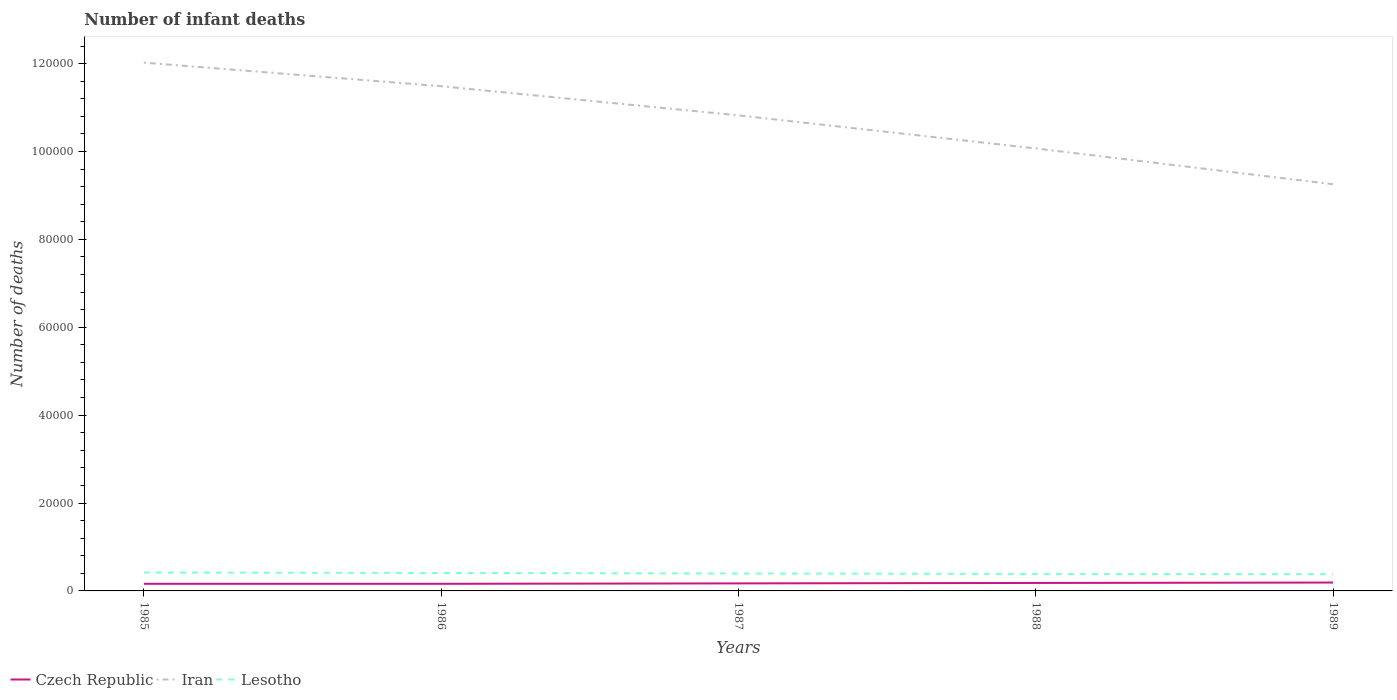How many different coloured lines are there?
Your response must be concise. 3. Is the number of lines equal to the number of legend labels?
Give a very brief answer. Yes. Across all years, what is the maximum number of infant deaths in Iran?
Offer a terse response. 9.25e+04. In which year was the number of infant deaths in Lesotho maximum?
Your answer should be compact. 1989. What is the total number of infant deaths in Czech Republic in the graph?
Provide a succinct answer. -283. What is the difference between the highest and the second highest number of infant deaths in Czech Republic?
Offer a terse response. 283. Is the number of infant deaths in Czech Republic strictly greater than the number of infant deaths in Iran over the years?
Your answer should be compact. Yes. How many lines are there?
Ensure brevity in your answer.  3. How many years are there in the graph?
Offer a terse response. 5. What is the difference between two consecutive major ticks on the Y-axis?
Provide a succinct answer. 2.00e+04. Does the graph contain grids?
Keep it short and to the point. No. What is the title of the graph?
Offer a terse response. Number of infant deaths. Does "Suriname" appear as one of the legend labels in the graph?
Your response must be concise. No. What is the label or title of the X-axis?
Ensure brevity in your answer.  Years. What is the label or title of the Y-axis?
Offer a terse response. Number of deaths. What is the Number of deaths of Czech Republic in 1985?
Offer a terse response. 1622. What is the Number of deaths in Iran in 1985?
Keep it short and to the point. 1.20e+05. What is the Number of deaths of Lesotho in 1985?
Make the answer very short. 4196. What is the Number of deaths in Czech Republic in 1986?
Offer a very short reply. 1622. What is the Number of deaths of Iran in 1986?
Ensure brevity in your answer.  1.15e+05. What is the Number of deaths of Lesotho in 1986?
Your answer should be very brief. 4080. What is the Number of deaths in Czech Republic in 1987?
Keep it short and to the point. 1714. What is the Number of deaths in Iran in 1987?
Your answer should be compact. 1.08e+05. What is the Number of deaths in Lesotho in 1987?
Offer a very short reply. 3973. What is the Number of deaths of Czech Republic in 1988?
Offer a terse response. 1814. What is the Number of deaths of Iran in 1988?
Your answer should be very brief. 1.01e+05. What is the Number of deaths of Lesotho in 1988?
Keep it short and to the point. 3871. What is the Number of deaths of Czech Republic in 1989?
Make the answer very short. 1905. What is the Number of deaths of Iran in 1989?
Your answer should be very brief. 9.25e+04. What is the Number of deaths in Lesotho in 1989?
Your answer should be compact. 3809. Across all years, what is the maximum Number of deaths in Czech Republic?
Make the answer very short. 1905. Across all years, what is the maximum Number of deaths in Iran?
Offer a very short reply. 1.20e+05. Across all years, what is the maximum Number of deaths of Lesotho?
Ensure brevity in your answer.  4196. Across all years, what is the minimum Number of deaths of Czech Republic?
Offer a terse response. 1622. Across all years, what is the minimum Number of deaths in Iran?
Make the answer very short. 9.25e+04. Across all years, what is the minimum Number of deaths of Lesotho?
Offer a very short reply. 3809. What is the total Number of deaths in Czech Republic in the graph?
Offer a very short reply. 8677. What is the total Number of deaths of Iran in the graph?
Your answer should be very brief. 5.37e+05. What is the total Number of deaths of Lesotho in the graph?
Ensure brevity in your answer.  1.99e+04. What is the difference between the Number of deaths of Iran in 1985 and that in 1986?
Make the answer very short. 5364. What is the difference between the Number of deaths in Lesotho in 1985 and that in 1986?
Your response must be concise. 116. What is the difference between the Number of deaths in Czech Republic in 1985 and that in 1987?
Your answer should be compact. -92. What is the difference between the Number of deaths of Iran in 1985 and that in 1987?
Your response must be concise. 1.20e+04. What is the difference between the Number of deaths of Lesotho in 1985 and that in 1987?
Make the answer very short. 223. What is the difference between the Number of deaths in Czech Republic in 1985 and that in 1988?
Your answer should be compact. -192. What is the difference between the Number of deaths of Iran in 1985 and that in 1988?
Your answer should be very brief. 1.95e+04. What is the difference between the Number of deaths of Lesotho in 1985 and that in 1988?
Make the answer very short. 325. What is the difference between the Number of deaths of Czech Republic in 1985 and that in 1989?
Your answer should be very brief. -283. What is the difference between the Number of deaths of Iran in 1985 and that in 1989?
Provide a short and direct response. 2.77e+04. What is the difference between the Number of deaths of Lesotho in 1985 and that in 1989?
Your answer should be very brief. 387. What is the difference between the Number of deaths in Czech Republic in 1986 and that in 1987?
Your answer should be compact. -92. What is the difference between the Number of deaths of Iran in 1986 and that in 1987?
Your answer should be very brief. 6638. What is the difference between the Number of deaths in Lesotho in 1986 and that in 1987?
Ensure brevity in your answer.  107. What is the difference between the Number of deaths of Czech Republic in 1986 and that in 1988?
Your answer should be compact. -192. What is the difference between the Number of deaths of Iran in 1986 and that in 1988?
Provide a short and direct response. 1.42e+04. What is the difference between the Number of deaths in Lesotho in 1986 and that in 1988?
Provide a succinct answer. 209. What is the difference between the Number of deaths in Czech Republic in 1986 and that in 1989?
Offer a very short reply. -283. What is the difference between the Number of deaths in Iran in 1986 and that in 1989?
Offer a very short reply. 2.23e+04. What is the difference between the Number of deaths in Lesotho in 1986 and that in 1989?
Offer a very short reply. 271. What is the difference between the Number of deaths of Czech Republic in 1987 and that in 1988?
Ensure brevity in your answer.  -100. What is the difference between the Number of deaths in Iran in 1987 and that in 1988?
Provide a short and direct response. 7524. What is the difference between the Number of deaths of Lesotho in 1987 and that in 1988?
Provide a succinct answer. 102. What is the difference between the Number of deaths in Czech Republic in 1987 and that in 1989?
Make the answer very short. -191. What is the difference between the Number of deaths of Iran in 1987 and that in 1989?
Your answer should be very brief. 1.57e+04. What is the difference between the Number of deaths in Lesotho in 1987 and that in 1989?
Your answer should be very brief. 164. What is the difference between the Number of deaths in Czech Republic in 1988 and that in 1989?
Offer a very short reply. -91. What is the difference between the Number of deaths in Iran in 1988 and that in 1989?
Offer a terse response. 8149. What is the difference between the Number of deaths of Czech Republic in 1985 and the Number of deaths of Iran in 1986?
Offer a terse response. -1.13e+05. What is the difference between the Number of deaths in Czech Republic in 1985 and the Number of deaths in Lesotho in 1986?
Offer a terse response. -2458. What is the difference between the Number of deaths of Iran in 1985 and the Number of deaths of Lesotho in 1986?
Provide a succinct answer. 1.16e+05. What is the difference between the Number of deaths in Czech Republic in 1985 and the Number of deaths in Iran in 1987?
Offer a very short reply. -1.07e+05. What is the difference between the Number of deaths of Czech Republic in 1985 and the Number of deaths of Lesotho in 1987?
Provide a succinct answer. -2351. What is the difference between the Number of deaths in Iran in 1985 and the Number of deaths in Lesotho in 1987?
Ensure brevity in your answer.  1.16e+05. What is the difference between the Number of deaths of Czech Republic in 1985 and the Number of deaths of Iran in 1988?
Ensure brevity in your answer.  -9.91e+04. What is the difference between the Number of deaths of Czech Republic in 1985 and the Number of deaths of Lesotho in 1988?
Your response must be concise. -2249. What is the difference between the Number of deaths of Iran in 1985 and the Number of deaths of Lesotho in 1988?
Provide a short and direct response. 1.16e+05. What is the difference between the Number of deaths in Czech Republic in 1985 and the Number of deaths in Iran in 1989?
Offer a very short reply. -9.09e+04. What is the difference between the Number of deaths in Czech Republic in 1985 and the Number of deaths in Lesotho in 1989?
Your answer should be compact. -2187. What is the difference between the Number of deaths in Iran in 1985 and the Number of deaths in Lesotho in 1989?
Provide a succinct answer. 1.16e+05. What is the difference between the Number of deaths of Czech Republic in 1986 and the Number of deaths of Iran in 1987?
Provide a short and direct response. -1.07e+05. What is the difference between the Number of deaths of Czech Republic in 1986 and the Number of deaths of Lesotho in 1987?
Keep it short and to the point. -2351. What is the difference between the Number of deaths of Iran in 1986 and the Number of deaths of Lesotho in 1987?
Offer a very short reply. 1.11e+05. What is the difference between the Number of deaths of Czech Republic in 1986 and the Number of deaths of Iran in 1988?
Offer a very short reply. -9.91e+04. What is the difference between the Number of deaths of Czech Republic in 1986 and the Number of deaths of Lesotho in 1988?
Offer a terse response. -2249. What is the difference between the Number of deaths of Iran in 1986 and the Number of deaths of Lesotho in 1988?
Ensure brevity in your answer.  1.11e+05. What is the difference between the Number of deaths in Czech Republic in 1986 and the Number of deaths in Iran in 1989?
Your answer should be very brief. -9.09e+04. What is the difference between the Number of deaths of Czech Republic in 1986 and the Number of deaths of Lesotho in 1989?
Give a very brief answer. -2187. What is the difference between the Number of deaths of Iran in 1986 and the Number of deaths of Lesotho in 1989?
Your response must be concise. 1.11e+05. What is the difference between the Number of deaths in Czech Republic in 1987 and the Number of deaths in Iran in 1988?
Make the answer very short. -9.90e+04. What is the difference between the Number of deaths in Czech Republic in 1987 and the Number of deaths in Lesotho in 1988?
Offer a very short reply. -2157. What is the difference between the Number of deaths in Iran in 1987 and the Number of deaths in Lesotho in 1988?
Your answer should be compact. 1.04e+05. What is the difference between the Number of deaths of Czech Republic in 1987 and the Number of deaths of Iran in 1989?
Provide a succinct answer. -9.08e+04. What is the difference between the Number of deaths of Czech Republic in 1987 and the Number of deaths of Lesotho in 1989?
Keep it short and to the point. -2095. What is the difference between the Number of deaths of Iran in 1987 and the Number of deaths of Lesotho in 1989?
Provide a short and direct response. 1.04e+05. What is the difference between the Number of deaths of Czech Republic in 1988 and the Number of deaths of Iran in 1989?
Offer a terse response. -9.07e+04. What is the difference between the Number of deaths in Czech Republic in 1988 and the Number of deaths in Lesotho in 1989?
Ensure brevity in your answer.  -1995. What is the difference between the Number of deaths in Iran in 1988 and the Number of deaths in Lesotho in 1989?
Provide a succinct answer. 9.69e+04. What is the average Number of deaths in Czech Republic per year?
Make the answer very short. 1735.4. What is the average Number of deaths of Iran per year?
Keep it short and to the point. 1.07e+05. What is the average Number of deaths in Lesotho per year?
Your answer should be compact. 3985.8. In the year 1985, what is the difference between the Number of deaths of Czech Republic and Number of deaths of Iran?
Offer a very short reply. -1.19e+05. In the year 1985, what is the difference between the Number of deaths in Czech Republic and Number of deaths in Lesotho?
Your answer should be very brief. -2574. In the year 1985, what is the difference between the Number of deaths in Iran and Number of deaths in Lesotho?
Offer a terse response. 1.16e+05. In the year 1986, what is the difference between the Number of deaths of Czech Republic and Number of deaths of Iran?
Ensure brevity in your answer.  -1.13e+05. In the year 1986, what is the difference between the Number of deaths of Czech Republic and Number of deaths of Lesotho?
Offer a terse response. -2458. In the year 1986, what is the difference between the Number of deaths in Iran and Number of deaths in Lesotho?
Give a very brief answer. 1.11e+05. In the year 1987, what is the difference between the Number of deaths of Czech Republic and Number of deaths of Iran?
Ensure brevity in your answer.  -1.07e+05. In the year 1987, what is the difference between the Number of deaths of Czech Republic and Number of deaths of Lesotho?
Offer a terse response. -2259. In the year 1987, what is the difference between the Number of deaths in Iran and Number of deaths in Lesotho?
Your answer should be compact. 1.04e+05. In the year 1988, what is the difference between the Number of deaths in Czech Republic and Number of deaths in Iran?
Keep it short and to the point. -9.89e+04. In the year 1988, what is the difference between the Number of deaths of Czech Republic and Number of deaths of Lesotho?
Offer a terse response. -2057. In the year 1988, what is the difference between the Number of deaths in Iran and Number of deaths in Lesotho?
Your response must be concise. 9.68e+04. In the year 1989, what is the difference between the Number of deaths of Czech Republic and Number of deaths of Iran?
Provide a short and direct response. -9.06e+04. In the year 1989, what is the difference between the Number of deaths of Czech Republic and Number of deaths of Lesotho?
Make the answer very short. -1904. In the year 1989, what is the difference between the Number of deaths in Iran and Number of deaths in Lesotho?
Provide a short and direct response. 8.87e+04. What is the ratio of the Number of deaths of Iran in 1985 to that in 1986?
Give a very brief answer. 1.05. What is the ratio of the Number of deaths in Lesotho in 1985 to that in 1986?
Provide a short and direct response. 1.03. What is the ratio of the Number of deaths in Czech Republic in 1985 to that in 1987?
Your response must be concise. 0.95. What is the ratio of the Number of deaths of Iran in 1985 to that in 1987?
Give a very brief answer. 1.11. What is the ratio of the Number of deaths in Lesotho in 1985 to that in 1987?
Your answer should be very brief. 1.06. What is the ratio of the Number of deaths of Czech Republic in 1985 to that in 1988?
Keep it short and to the point. 0.89. What is the ratio of the Number of deaths in Iran in 1985 to that in 1988?
Your response must be concise. 1.19. What is the ratio of the Number of deaths in Lesotho in 1985 to that in 1988?
Offer a very short reply. 1.08. What is the ratio of the Number of deaths in Czech Republic in 1985 to that in 1989?
Offer a very short reply. 0.85. What is the ratio of the Number of deaths of Iran in 1985 to that in 1989?
Your response must be concise. 1.3. What is the ratio of the Number of deaths in Lesotho in 1985 to that in 1989?
Your response must be concise. 1.1. What is the ratio of the Number of deaths in Czech Republic in 1986 to that in 1987?
Your answer should be very brief. 0.95. What is the ratio of the Number of deaths of Iran in 1986 to that in 1987?
Your response must be concise. 1.06. What is the ratio of the Number of deaths of Lesotho in 1986 to that in 1987?
Your answer should be compact. 1.03. What is the ratio of the Number of deaths of Czech Republic in 1986 to that in 1988?
Offer a terse response. 0.89. What is the ratio of the Number of deaths of Iran in 1986 to that in 1988?
Your response must be concise. 1.14. What is the ratio of the Number of deaths of Lesotho in 1986 to that in 1988?
Your response must be concise. 1.05. What is the ratio of the Number of deaths of Czech Republic in 1986 to that in 1989?
Your answer should be compact. 0.85. What is the ratio of the Number of deaths of Iran in 1986 to that in 1989?
Keep it short and to the point. 1.24. What is the ratio of the Number of deaths in Lesotho in 1986 to that in 1989?
Provide a succinct answer. 1.07. What is the ratio of the Number of deaths in Czech Republic in 1987 to that in 1988?
Your response must be concise. 0.94. What is the ratio of the Number of deaths of Iran in 1987 to that in 1988?
Your response must be concise. 1.07. What is the ratio of the Number of deaths of Lesotho in 1987 to that in 1988?
Make the answer very short. 1.03. What is the ratio of the Number of deaths of Czech Republic in 1987 to that in 1989?
Keep it short and to the point. 0.9. What is the ratio of the Number of deaths of Iran in 1987 to that in 1989?
Offer a very short reply. 1.17. What is the ratio of the Number of deaths in Lesotho in 1987 to that in 1989?
Your response must be concise. 1.04. What is the ratio of the Number of deaths of Czech Republic in 1988 to that in 1989?
Give a very brief answer. 0.95. What is the ratio of the Number of deaths of Iran in 1988 to that in 1989?
Provide a succinct answer. 1.09. What is the ratio of the Number of deaths in Lesotho in 1988 to that in 1989?
Keep it short and to the point. 1.02. What is the difference between the highest and the second highest Number of deaths of Czech Republic?
Make the answer very short. 91. What is the difference between the highest and the second highest Number of deaths of Iran?
Make the answer very short. 5364. What is the difference between the highest and the second highest Number of deaths of Lesotho?
Keep it short and to the point. 116. What is the difference between the highest and the lowest Number of deaths of Czech Republic?
Offer a terse response. 283. What is the difference between the highest and the lowest Number of deaths in Iran?
Offer a terse response. 2.77e+04. What is the difference between the highest and the lowest Number of deaths in Lesotho?
Your answer should be very brief. 387. 